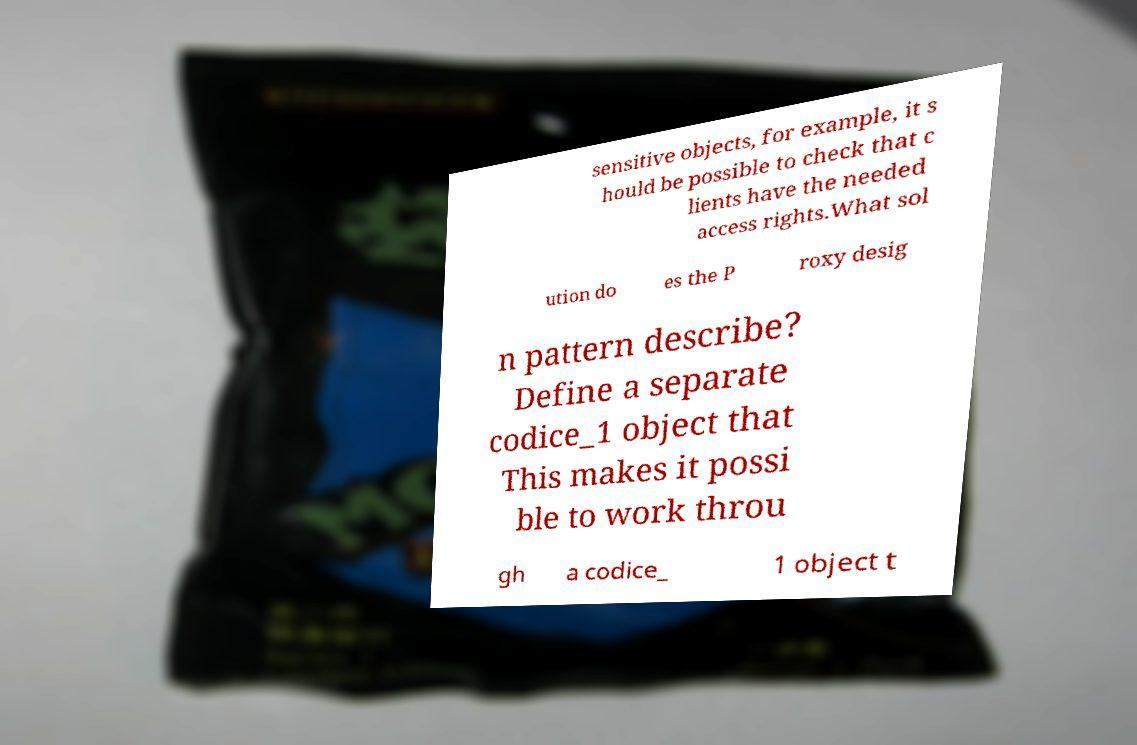I need the written content from this picture converted into text. Can you do that? sensitive objects, for example, it s hould be possible to check that c lients have the needed access rights.What sol ution do es the P roxy desig n pattern describe? Define a separate codice_1 object that This makes it possi ble to work throu gh a codice_ 1 object t 